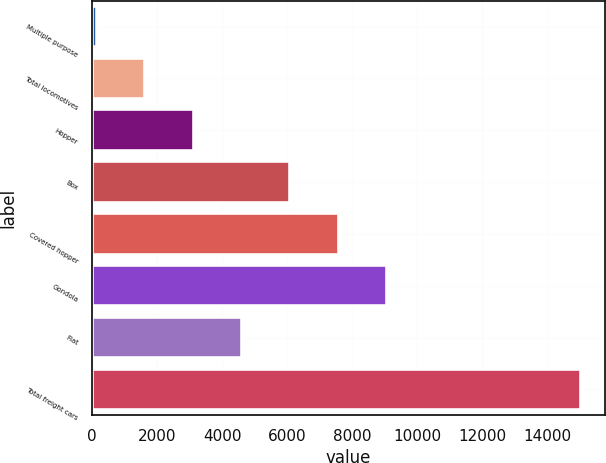Convert chart to OTSL. <chart><loc_0><loc_0><loc_500><loc_500><bar_chart><fcel>Multiple purpose<fcel>Total locomotives<fcel>Hopper<fcel>Box<fcel>Covered hopper<fcel>Gondola<fcel>Flat<fcel>Total freight cars<nl><fcel>151<fcel>1638.6<fcel>3126.2<fcel>6101.4<fcel>7589<fcel>9076.6<fcel>4613.8<fcel>15027<nl></chart> 